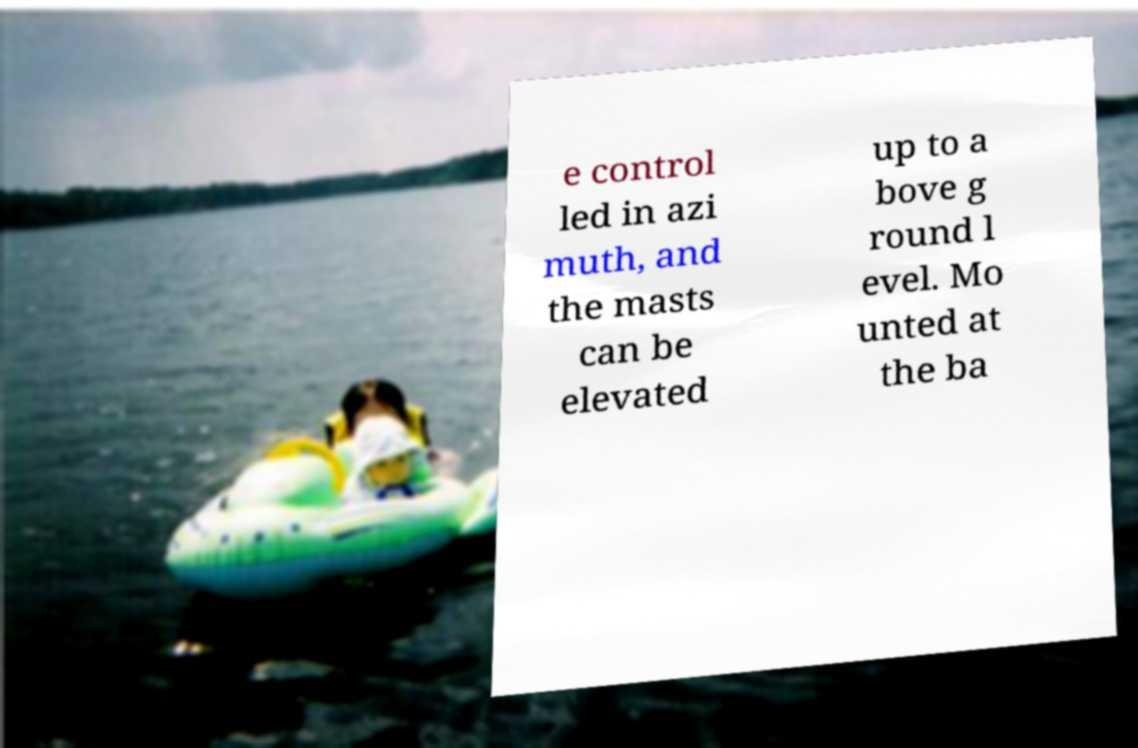Could you extract and type out the text from this image? e control led in azi muth, and the masts can be elevated up to a bove g round l evel. Mo unted at the ba 